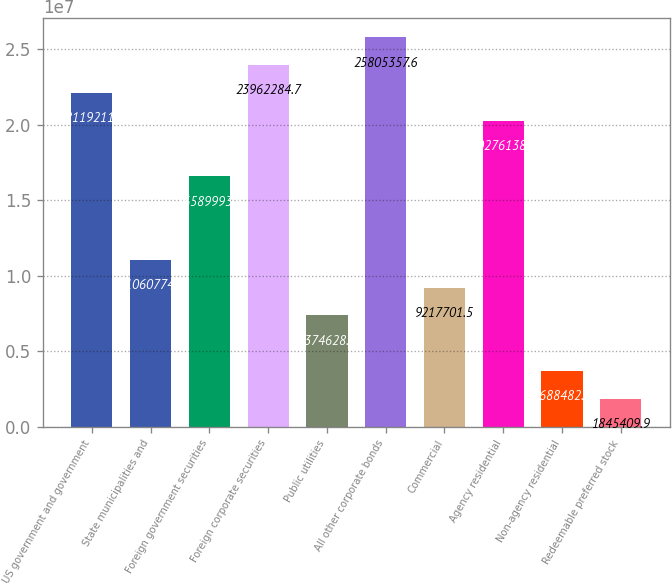Convert chart. <chart><loc_0><loc_0><loc_500><loc_500><bar_chart><fcel>US government and government<fcel>State municipalities and<fcel>Foreign government securities<fcel>Foreign corporate securities<fcel>Public utilities<fcel>All other corporate bonds<fcel>Commercial<fcel>Agency residential<fcel>Non-agency residential<fcel>Redeemable preferred stock<nl><fcel>2.21192e+07<fcel>1.10608e+07<fcel>1.659e+07<fcel>2.39623e+07<fcel>7.37463e+06<fcel>2.58054e+07<fcel>9.2177e+06<fcel>2.02761e+07<fcel>3.68848e+06<fcel>1.84541e+06<nl></chart> 